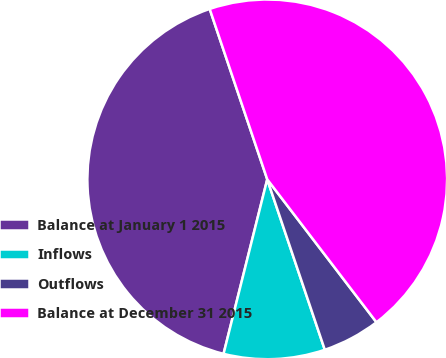<chart> <loc_0><loc_0><loc_500><loc_500><pie_chart><fcel>Balance at January 1 2015<fcel>Inflows<fcel>Outflows<fcel>Balance at December 31 2015<nl><fcel>40.91%<fcel>9.09%<fcel>5.2%<fcel>44.8%<nl></chart> 